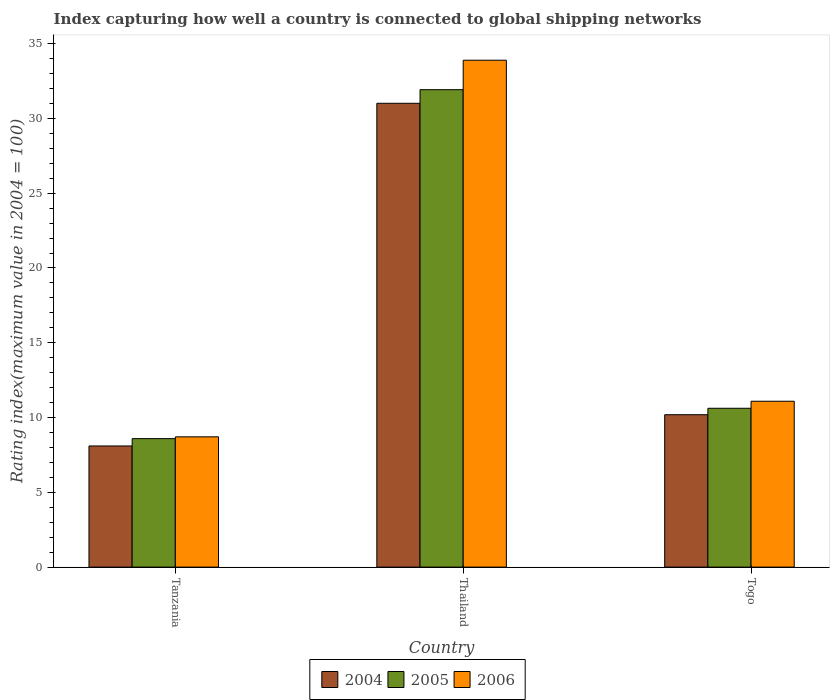How many different coloured bars are there?
Your answer should be very brief. 3. How many groups of bars are there?
Your response must be concise. 3. Are the number of bars on each tick of the X-axis equal?
Give a very brief answer. Yes. How many bars are there on the 3rd tick from the right?
Give a very brief answer. 3. What is the label of the 3rd group of bars from the left?
Provide a succinct answer. Togo. In how many cases, is the number of bars for a given country not equal to the number of legend labels?
Offer a terse response. 0. What is the rating index in 2004 in Thailand?
Provide a succinct answer. 31.01. Across all countries, what is the maximum rating index in 2005?
Ensure brevity in your answer.  31.92. Across all countries, what is the minimum rating index in 2005?
Ensure brevity in your answer.  8.59. In which country was the rating index in 2005 maximum?
Make the answer very short. Thailand. In which country was the rating index in 2004 minimum?
Make the answer very short. Tanzania. What is the total rating index in 2006 in the graph?
Offer a very short reply. 53.69. What is the difference between the rating index in 2004 in Tanzania and that in Thailand?
Give a very brief answer. -22.91. What is the difference between the rating index in 2005 in Thailand and the rating index in 2004 in Tanzania?
Keep it short and to the point. 23.82. What is the average rating index in 2004 per country?
Ensure brevity in your answer.  16.43. What is the difference between the rating index of/in 2004 and rating index of/in 2005 in Togo?
Make the answer very short. -0.43. What is the ratio of the rating index in 2005 in Thailand to that in Togo?
Offer a terse response. 3.01. What is the difference between the highest and the second highest rating index in 2005?
Your answer should be very brief. -2.03. What is the difference between the highest and the lowest rating index in 2006?
Keep it short and to the point. 25.18. In how many countries, is the rating index in 2005 greater than the average rating index in 2005 taken over all countries?
Your response must be concise. 1. Is the sum of the rating index in 2006 in Thailand and Togo greater than the maximum rating index in 2005 across all countries?
Keep it short and to the point. Yes. What does the 3rd bar from the left in Thailand represents?
Keep it short and to the point. 2006. What is the difference between two consecutive major ticks on the Y-axis?
Your response must be concise. 5. Are the values on the major ticks of Y-axis written in scientific E-notation?
Your answer should be compact. No. Does the graph contain any zero values?
Keep it short and to the point. No. How many legend labels are there?
Ensure brevity in your answer.  3. What is the title of the graph?
Make the answer very short. Index capturing how well a country is connected to global shipping networks. What is the label or title of the X-axis?
Make the answer very short. Country. What is the label or title of the Y-axis?
Make the answer very short. Rating index(maximum value in 2004 = 100). What is the Rating index(maximum value in 2004 = 100) in 2005 in Tanzania?
Keep it short and to the point. 8.59. What is the Rating index(maximum value in 2004 = 100) in 2006 in Tanzania?
Give a very brief answer. 8.71. What is the Rating index(maximum value in 2004 = 100) in 2004 in Thailand?
Keep it short and to the point. 31.01. What is the Rating index(maximum value in 2004 = 100) of 2005 in Thailand?
Your answer should be compact. 31.92. What is the Rating index(maximum value in 2004 = 100) in 2006 in Thailand?
Provide a short and direct response. 33.89. What is the Rating index(maximum value in 2004 = 100) in 2004 in Togo?
Give a very brief answer. 10.19. What is the Rating index(maximum value in 2004 = 100) in 2005 in Togo?
Make the answer very short. 10.62. What is the Rating index(maximum value in 2004 = 100) in 2006 in Togo?
Your answer should be compact. 11.09. Across all countries, what is the maximum Rating index(maximum value in 2004 = 100) in 2004?
Your answer should be compact. 31.01. Across all countries, what is the maximum Rating index(maximum value in 2004 = 100) in 2005?
Give a very brief answer. 31.92. Across all countries, what is the maximum Rating index(maximum value in 2004 = 100) of 2006?
Make the answer very short. 33.89. Across all countries, what is the minimum Rating index(maximum value in 2004 = 100) of 2005?
Provide a short and direct response. 8.59. Across all countries, what is the minimum Rating index(maximum value in 2004 = 100) in 2006?
Provide a short and direct response. 8.71. What is the total Rating index(maximum value in 2004 = 100) of 2004 in the graph?
Offer a very short reply. 49.3. What is the total Rating index(maximum value in 2004 = 100) of 2005 in the graph?
Your answer should be compact. 51.13. What is the total Rating index(maximum value in 2004 = 100) of 2006 in the graph?
Ensure brevity in your answer.  53.69. What is the difference between the Rating index(maximum value in 2004 = 100) in 2004 in Tanzania and that in Thailand?
Ensure brevity in your answer.  -22.91. What is the difference between the Rating index(maximum value in 2004 = 100) of 2005 in Tanzania and that in Thailand?
Make the answer very short. -23.33. What is the difference between the Rating index(maximum value in 2004 = 100) of 2006 in Tanzania and that in Thailand?
Your response must be concise. -25.18. What is the difference between the Rating index(maximum value in 2004 = 100) in 2004 in Tanzania and that in Togo?
Make the answer very short. -2.09. What is the difference between the Rating index(maximum value in 2004 = 100) of 2005 in Tanzania and that in Togo?
Give a very brief answer. -2.03. What is the difference between the Rating index(maximum value in 2004 = 100) of 2006 in Tanzania and that in Togo?
Your answer should be very brief. -2.38. What is the difference between the Rating index(maximum value in 2004 = 100) in 2004 in Thailand and that in Togo?
Ensure brevity in your answer.  20.82. What is the difference between the Rating index(maximum value in 2004 = 100) in 2005 in Thailand and that in Togo?
Ensure brevity in your answer.  21.3. What is the difference between the Rating index(maximum value in 2004 = 100) of 2006 in Thailand and that in Togo?
Your response must be concise. 22.8. What is the difference between the Rating index(maximum value in 2004 = 100) in 2004 in Tanzania and the Rating index(maximum value in 2004 = 100) in 2005 in Thailand?
Provide a succinct answer. -23.82. What is the difference between the Rating index(maximum value in 2004 = 100) of 2004 in Tanzania and the Rating index(maximum value in 2004 = 100) of 2006 in Thailand?
Give a very brief answer. -25.79. What is the difference between the Rating index(maximum value in 2004 = 100) of 2005 in Tanzania and the Rating index(maximum value in 2004 = 100) of 2006 in Thailand?
Offer a very short reply. -25.3. What is the difference between the Rating index(maximum value in 2004 = 100) in 2004 in Tanzania and the Rating index(maximum value in 2004 = 100) in 2005 in Togo?
Provide a succinct answer. -2.52. What is the difference between the Rating index(maximum value in 2004 = 100) in 2004 in Tanzania and the Rating index(maximum value in 2004 = 100) in 2006 in Togo?
Ensure brevity in your answer.  -2.99. What is the difference between the Rating index(maximum value in 2004 = 100) of 2005 in Tanzania and the Rating index(maximum value in 2004 = 100) of 2006 in Togo?
Provide a short and direct response. -2.5. What is the difference between the Rating index(maximum value in 2004 = 100) in 2004 in Thailand and the Rating index(maximum value in 2004 = 100) in 2005 in Togo?
Offer a terse response. 20.39. What is the difference between the Rating index(maximum value in 2004 = 100) in 2004 in Thailand and the Rating index(maximum value in 2004 = 100) in 2006 in Togo?
Give a very brief answer. 19.92. What is the difference between the Rating index(maximum value in 2004 = 100) of 2005 in Thailand and the Rating index(maximum value in 2004 = 100) of 2006 in Togo?
Your response must be concise. 20.83. What is the average Rating index(maximum value in 2004 = 100) in 2004 per country?
Keep it short and to the point. 16.43. What is the average Rating index(maximum value in 2004 = 100) in 2005 per country?
Your answer should be compact. 17.04. What is the average Rating index(maximum value in 2004 = 100) in 2006 per country?
Give a very brief answer. 17.9. What is the difference between the Rating index(maximum value in 2004 = 100) of 2004 and Rating index(maximum value in 2004 = 100) of 2005 in Tanzania?
Offer a very short reply. -0.49. What is the difference between the Rating index(maximum value in 2004 = 100) of 2004 and Rating index(maximum value in 2004 = 100) of 2006 in Tanzania?
Provide a succinct answer. -0.61. What is the difference between the Rating index(maximum value in 2004 = 100) in 2005 and Rating index(maximum value in 2004 = 100) in 2006 in Tanzania?
Your answer should be compact. -0.12. What is the difference between the Rating index(maximum value in 2004 = 100) in 2004 and Rating index(maximum value in 2004 = 100) in 2005 in Thailand?
Offer a very short reply. -0.91. What is the difference between the Rating index(maximum value in 2004 = 100) in 2004 and Rating index(maximum value in 2004 = 100) in 2006 in Thailand?
Provide a short and direct response. -2.88. What is the difference between the Rating index(maximum value in 2004 = 100) in 2005 and Rating index(maximum value in 2004 = 100) in 2006 in Thailand?
Offer a terse response. -1.97. What is the difference between the Rating index(maximum value in 2004 = 100) in 2004 and Rating index(maximum value in 2004 = 100) in 2005 in Togo?
Offer a very short reply. -0.43. What is the difference between the Rating index(maximum value in 2004 = 100) of 2004 and Rating index(maximum value in 2004 = 100) of 2006 in Togo?
Your answer should be very brief. -0.9. What is the difference between the Rating index(maximum value in 2004 = 100) in 2005 and Rating index(maximum value in 2004 = 100) in 2006 in Togo?
Make the answer very short. -0.47. What is the ratio of the Rating index(maximum value in 2004 = 100) of 2004 in Tanzania to that in Thailand?
Provide a succinct answer. 0.26. What is the ratio of the Rating index(maximum value in 2004 = 100) in 2005 in Tanzania to that in Thailand?
Keep it short and to the point. 0.27. What is the ratio of the Rating index(maximum value in 2004 = 100) of 2006 in Tanzania to that in Thailand?
Your answer should be very brief. 0.26. What is the ratio of the Rating index(maximum value in 2004 = 100) of 2004 in Tanzania to that in Togo?
Your answer should be very brief. 0.79. What is the ratio of the Rating index(maximum value in 2004 = 100) in 2005 in Tanzania to that in Togo?
Make the answer very short. 0.81. What is the ratio of the Rating index(maximum value in 2004 = 100) of 2006 in Tanzania to that in Togo?
Provide a succinct answer. 0.79. What is the ratio of the Rating index(maximum value in 2004 = 100) in 2004 in Thailand to that in Togo?
Ensure brevity in your answer.  3.04. What is the ratio of the Rating index(maximum value in 2004 = 100) of 2005 in Thailand to that in Togo?
Your response must be concise. 3.01. What is the ratio of the Rating index(maximum value in 2004 = 100) in 2006 in Thailand to that in Togo?
Give a very brief answer. 3.06. What is the difference between the highest and the second highest Rating index(maximum value in 2004 = 100) in 2004?
Provide a succinct answer. 20.82. What is the difference between the highest and the second highest Rating index(maximum value in 2004 = 100) in 2005?
Provide a short and direct response. 21.3. What is the difference between the highest and the second highest Rating index(maximum value in 2004 = 100) in 2006?
Provide a short and direct response. 22.8. What is the difference between the highest and the lowest Rating index(maximum value in 2004 = 100) of 2004?
Provide a succinct answer. 22.91. What is the difference between the highest and the lowest Rating index(maximum value in 2004 = 100) of 2005?
Offer a very short reply. 23.33. What is the difference between the highest and the lowest Rating index(maximum value in 2004 = 100) of 2006?
Your response must be concise. 25.18. 